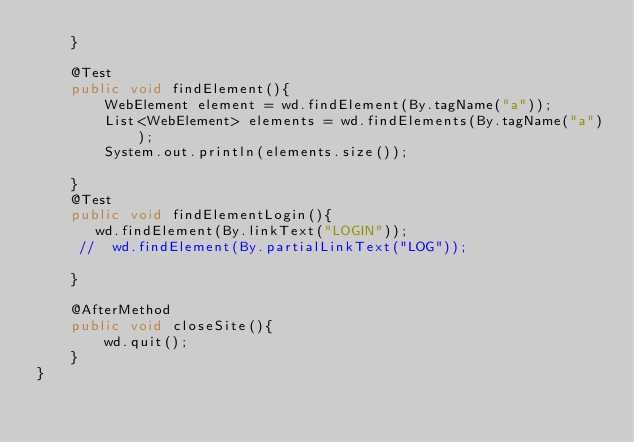<code> <loc_0><loc_0><loc_500><loc_500><_Java_>    }

    @Test
    public void findElement(){
        WebElement element = wd.findElement(By.tagName("a"));
        List<WebElement> elements = wd.findElements(By.tagName("a"));
        System.out.println(elements.size());

    }
    @Test
    public void findElementLogin(){
       wd.findElement(By.linkText("LOGIN"));
     //  wd.findElement(By.partialLinkText("LOG"));

    }

    @AfterMethod
    public void closeSite(){
        wd.quit();
    }
}
</code> 